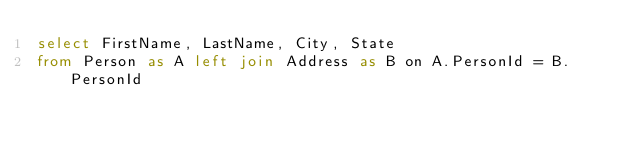<code> <loc_0><loc_0><loc_500><loc_500><_SQL_>select FirstName, LastName, City, State
from Person as A left join Address as B on A.PersonId = B.PersonId</code> 